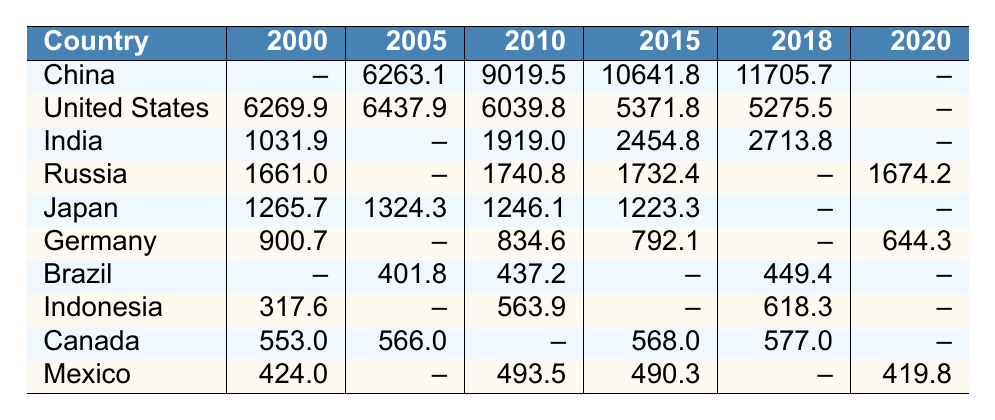What is the highest greenhouse gas emission recorded in 2015? Looking at the emissions for 2015, the values are as follows: China (10641.8), United States (5371.8), India (2454.8), Russia (1732.4), Japan (1223.3), Germany (792.1), Brazil (--), Indonesia (--), Canada (568.0), and Mexico (490.3). The highest value is 10641.8 from China.
Answer: 10641.8 Which country reported greenhouse gas emissions in every year listed? By examining the table, the United States is noted to have data for every year from 2000 to 2018. Other countries lack records for some years, hence the United States is the only country with complete data.
Answer: United States What is the difference in greenhouse gas emissions between China in 2010 and India in 2010? China had emissions of 9019.5 in 2010 and India had emissions of 1919.0. The difference is 9019.5 - 1919.0 = 7100.5.
Answer: 7100.5 Is it true that Germany's emissions decreased from 2000 to 2020? For Germany, the emissions were 900.7 in 2000 and decreased to 644.3 in 2020. This confirms that emissions did indeed decrease over that period.
Answer: Yes What is the average greenhouse gas emission for Canada from the years reported? Canada has emissions for the years 2000 (553.0), 2005 (566.0), 2015 (568.0), and 2018 (577.0), totaling 553.0 + 566.0 + 568.0 + 577.0 = 2264.0. Dividing by the 4 years gives an average of 2264.0 / 4 = 566.0.
Answer: 566.0 Which country saw an increase in emissions from 2010 to 2018? By tracking the emissions in 2010 and 2018, India increased from 1919.0 to 2713.8, which is an increase. No other country demonstrated this in the given years.
Answer: India What was the total greenhouse gas emissions reported for Japan from 2000 to 2015? Japan's emissions for the reported years are 1265.7 (2000), 1324.3 (2005), 1246.1 (2010), and 1223.3 (2015). Adding these gives 1265.7 + 1324.3 + 1246.1 + 1223.3 = 5059.4.
Answer: 5059.4 Did Brazil report emissions for the year 2000? Brazil had no emissions reported for 2000, evidenced by the lack of a value in that row for that year in the table.
Answer: No Which country had the lowest greenhouse gas emissions in the year 2005? According to the 2005 data, the emissions figures are: China (6263.1), United States (6437.9), Brazil (401.8), all others omitted. The lowest recorded is Brazil with 401.8.
Answer: Brazil What are the emissions for Russia in 2020 compared to 2010? Russia reported emissions of 1740.8 in 2010 and 1674.2 in 2020, indicating a decrease from 1740.8 to 1674.2.
Answer: Decrease Calculate the greenhouse gas emissions for India from 2000 to 2018. India had emissions of 1031.9 in 2000, no report for 2005, 1919.0 in 2010, 2454.8 in 2015, and 2713.8 in 2018. The total is 1031.9 + 0 + 1919.0 + 2454.8 + 2713.8 = 8119.5.
Answer: 8119.5 